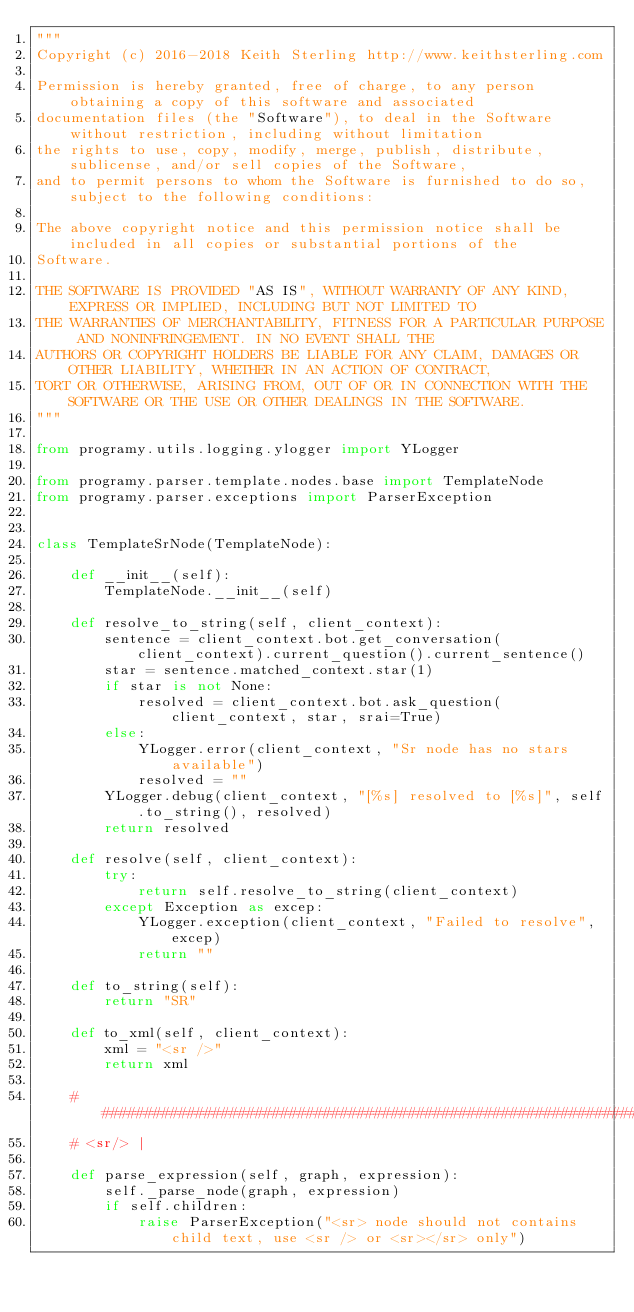<code> <loc_0><loc_0><loc_500><loc_500><_Python_>"""
Copyright (c) 2016-2018 Keith Sterling http://www.keithsterling.com

Permission is hereby granted, free of charge, to any person obtaining a copy of this software and associated
documentation files (the "Software"), to deal in the Software without restriction, including without limitation
the rights to use, copy, modify, merge, publish, distribute, sublicense, and/or sell copies of the Software,
and to permit persons to whom the Software is furnished to do so, subject to the following conditions:

The above copyright notice and this permission notice shall be included in all copies or substantial portions of the
Software.

THE SOFTWARE IS PROVIDED "AS IS", WITHOUT WARRANTY OF ANY KIND, EXPRESS OR IMPLIED, INCLUDING BUT NOT LIMITED TO
THE WARRANTIES OF MERCHANTABILITY, FITNESS FOR A PARTICULAR PURPOSE AND NONINFRINGEMENT. IN NO EVENT SHALL THE
AUTHORS OR COPYRIGHT HOLDERS BE LIABLE FOR ANY CLAIM, DAMAGES OR OTHER LIABILITY, WHETHER IN AN ACTION OF CONTRACT,
TORT OR OTHERWISE, ARISING FROM, OUT OF OR IN CONNECTION WITH THE SOFTWARE OR THE USE OR OTHER DEALINGS IN THE SOFTWARE.
"""

from programy.utils.logging.ylogger import YLogger

from programy.parser.template.nodes.base import TemplateNode
from programy.parser.exceptions import ParserException


class TemplateSrNode(TemplateNode):

    def __init__(self):
        TemplateNode.__init__(self)

    def resolve_to_string(self, client_context):
        sentence = client_context.bot.get_conversation(client_context).current_question().current_sentence()
        star = sentence.matched_context.star(1)
        if star is not None:
            resolved = client_context.bot.ask_question(client_context, star, srai=True)
        else:
            YLogger.error(client_context, "Sr node has no stars available")
            resolved = ""
        YLogger.debug(client_context, "[%s] resolved to [%s]", self.to_string(), resolved)
        return resolved

    def resolve(self, client_context):
        try:
            return self.resolve_to_string(client_context)
        except Exception as excep:
            YLogger.exception(client_context, "Failed to resolve", excep)
            return ""

    def to_string(self):
        return "SR"

    def to_xml(self, client_context):
        xml = "<sr />"
        return xml

    #######################################################################################################
    # <sr/> |

    def parse_expression(self, graph, expression):
        self._parse_node(graph, expression)
        if self.children:
            raise ParserException("<sr> node should not contains child text, use <sr /> or <sr></sr> only")
</code> 